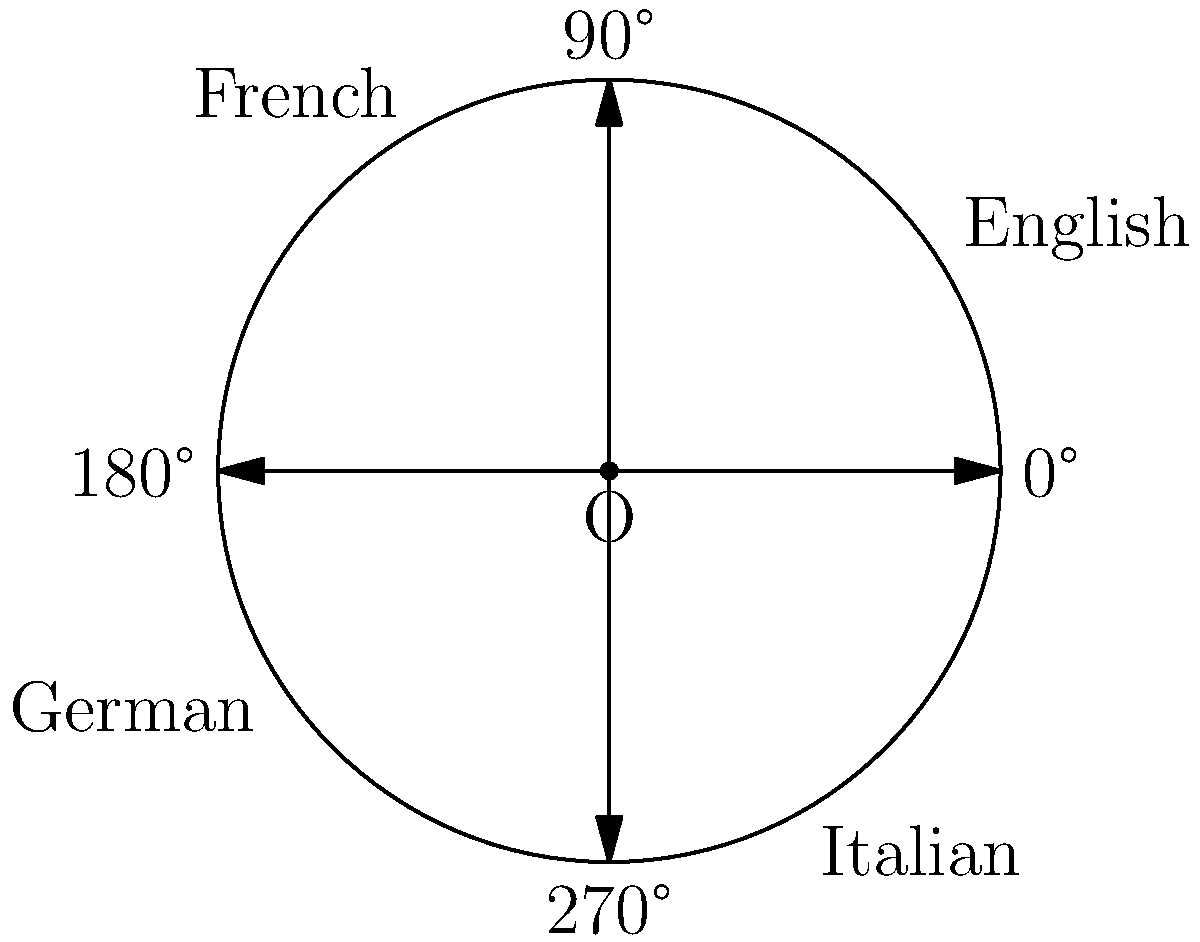As a translator working on a multilingual document layout, you're arranging text samples in English, French, German, and Italian around a central point. English is positioned at 30°, French at 120°, German at 210°, and Italian at 300°. What is the smallest positive angle between the French and German text samples? To find the smallest positive angle between the French and German text samples, we need to follow these steps:

1. Identify the angles for French and German:
   French: 120°
   German: 210°

2. Calculate the difference between these angles:
   $210° - 120° = 90°$

3. Consider that the smallest positive angle could be either this difference or its complement to 360°:
   Complement = $360° - 90° = 270°$

4. Compare the two possible angles:
   $90°$ and $270°$

5. Choose the smaller of the two angles:
   The smaller angle is $90°$

Therefore, the smallest positive angle between the French and German text samples is 90°.
Answer: 90° 